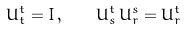Convert formula to latex. <formula><loc_0><loc_0><loc_500><loc_500>U _ { t } ^ { t } = I \, , \quad U _ { s } ^ { t } \, U _ { r } ^ { s } = U _ { r } ^ { t }</formula> 